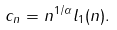<formula> <loc_0><loc_0><loc_500><loc_500>c _ { n } = n ^ { 1 / \alpha } l _ { 1 } ( n ) .</formula> 